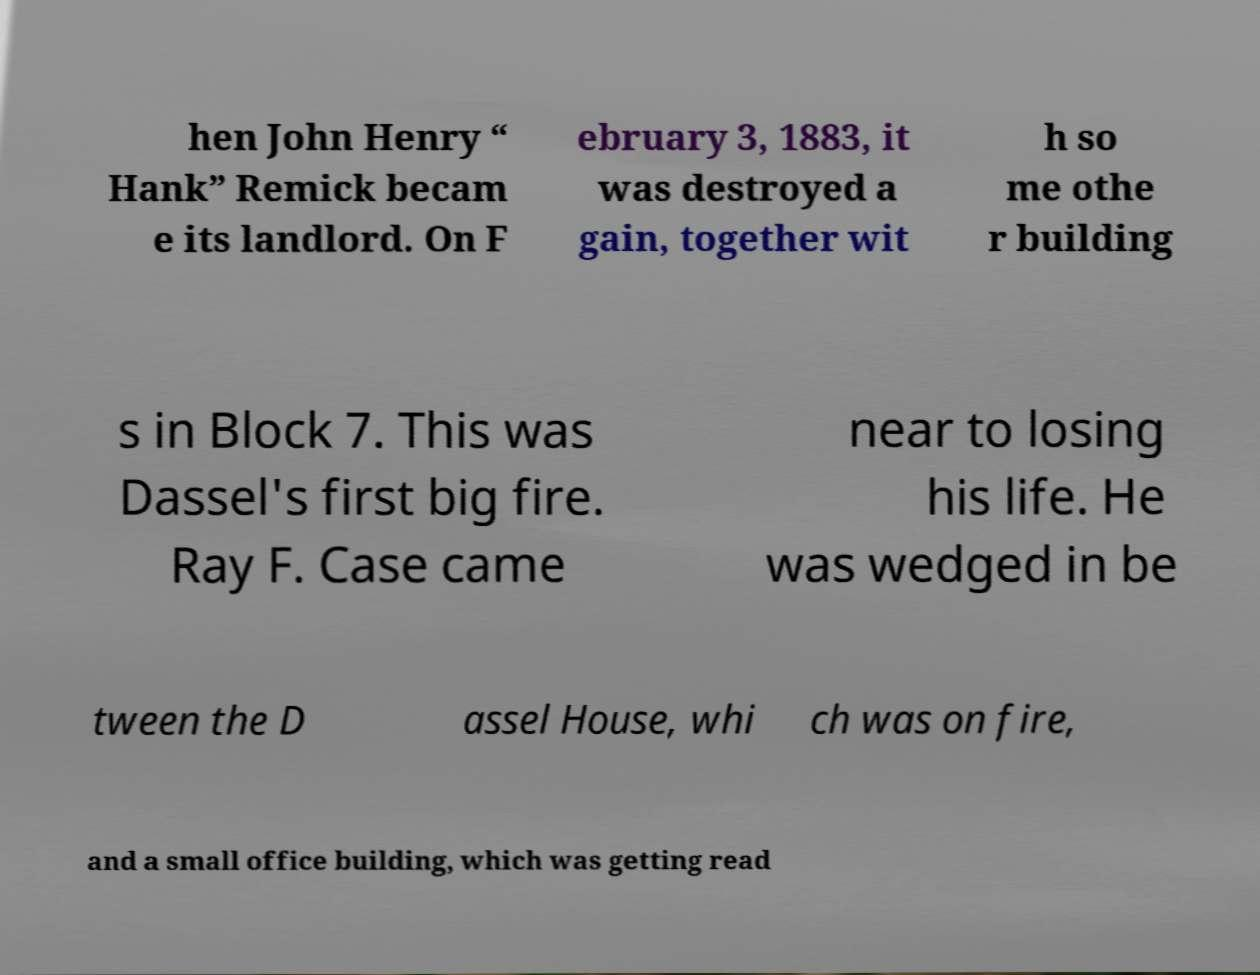Please identify and transcribe the text found in this image. hen John Henry “ Hank” Remick becam e its landlord. On F ebruary 3, 1883, it was destroyed a gain, together wit h so me othe r building s in Block 7. This was Dassel's first big fire. Ray F. Case came near to losing his life. He was wedged in be tween the D assel House, whi ch was on fire, and a small office building, which was getting read 